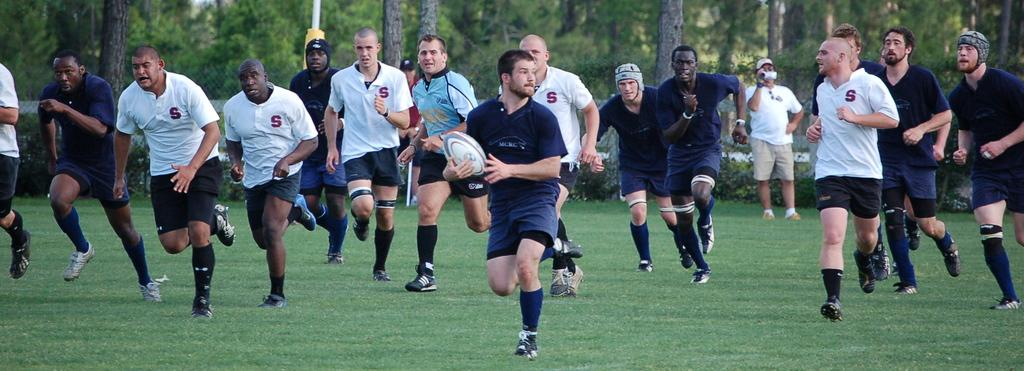What are the people in the image doing? The people in the image are running on the ground. What is the surface they are running on? The ground is covered with grass. Can you identify any objects being held by the people in the image? Yes, a person is holding a rugby ball in his hand. What type of skin condition can be seen on the person holding the rugby ball? There is no indication of any skin condition on the person holding the rugby ball in the image. 